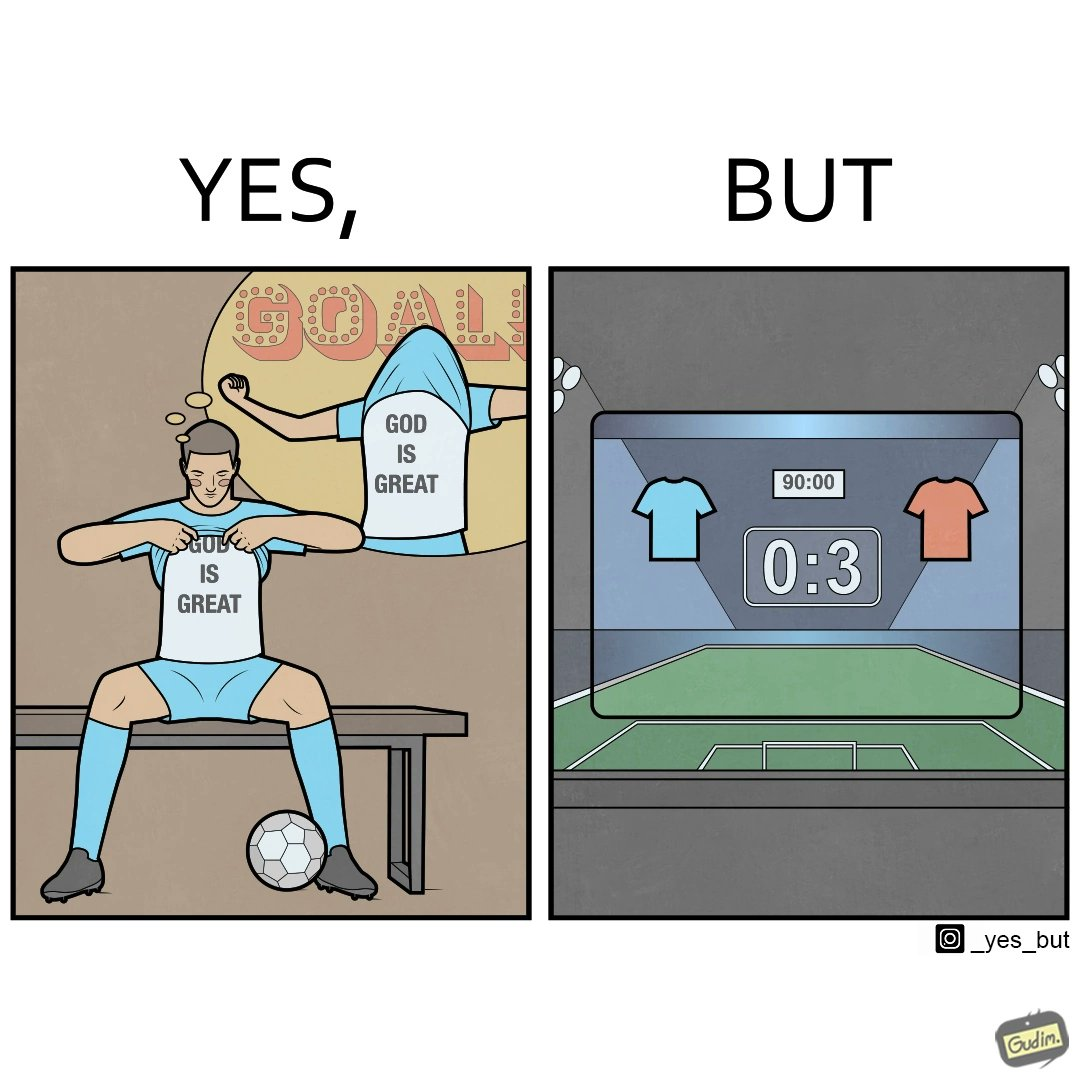Would you classify this image as satirical? Yes, this image is satirical. 